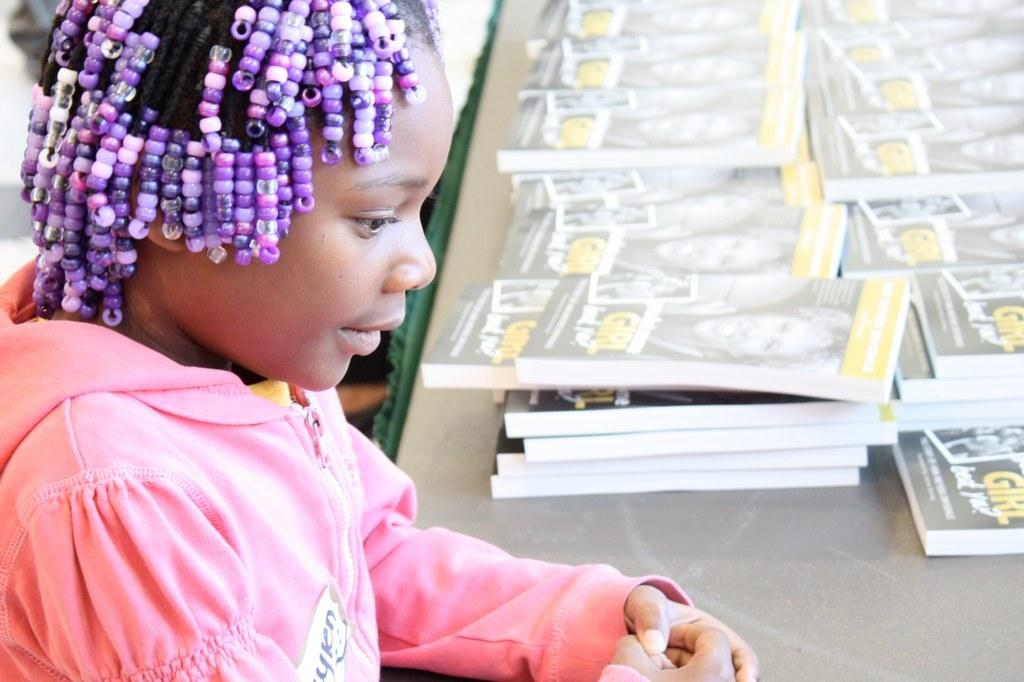Who is on the left side of the image? There is a girl on the left side of the image. What is in front of the girl? There is a table in front of the girl. What is on top of the table? There are books on top of the table. What type of egg is being used to represent the nation in the image? There is no egg or representation of a nation present in the image. 